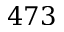Convert formula to latex. <formula><loc_0><loc_0><loc_500><loc_500>4 7 3</formula> 